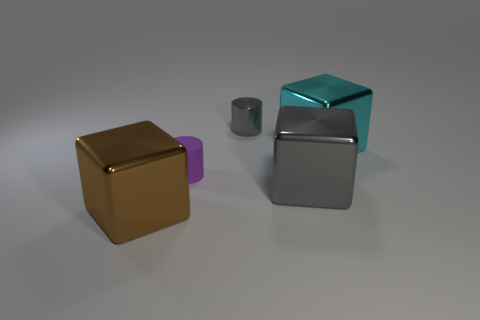Add 5 gray blocks. How many objects exist? 10 Subtract all cylinders. How many objects are left? 3 Add 3 tiny things. How many tiny things are left? 5 Add 4 big gray metal blocks. How many big gray metal blocks exist? 5 Subtract 0 blue cylinders. How many objects are left? 5 Subtract all purple matte things. Subtract all big blocks. How many objects are left? 1 